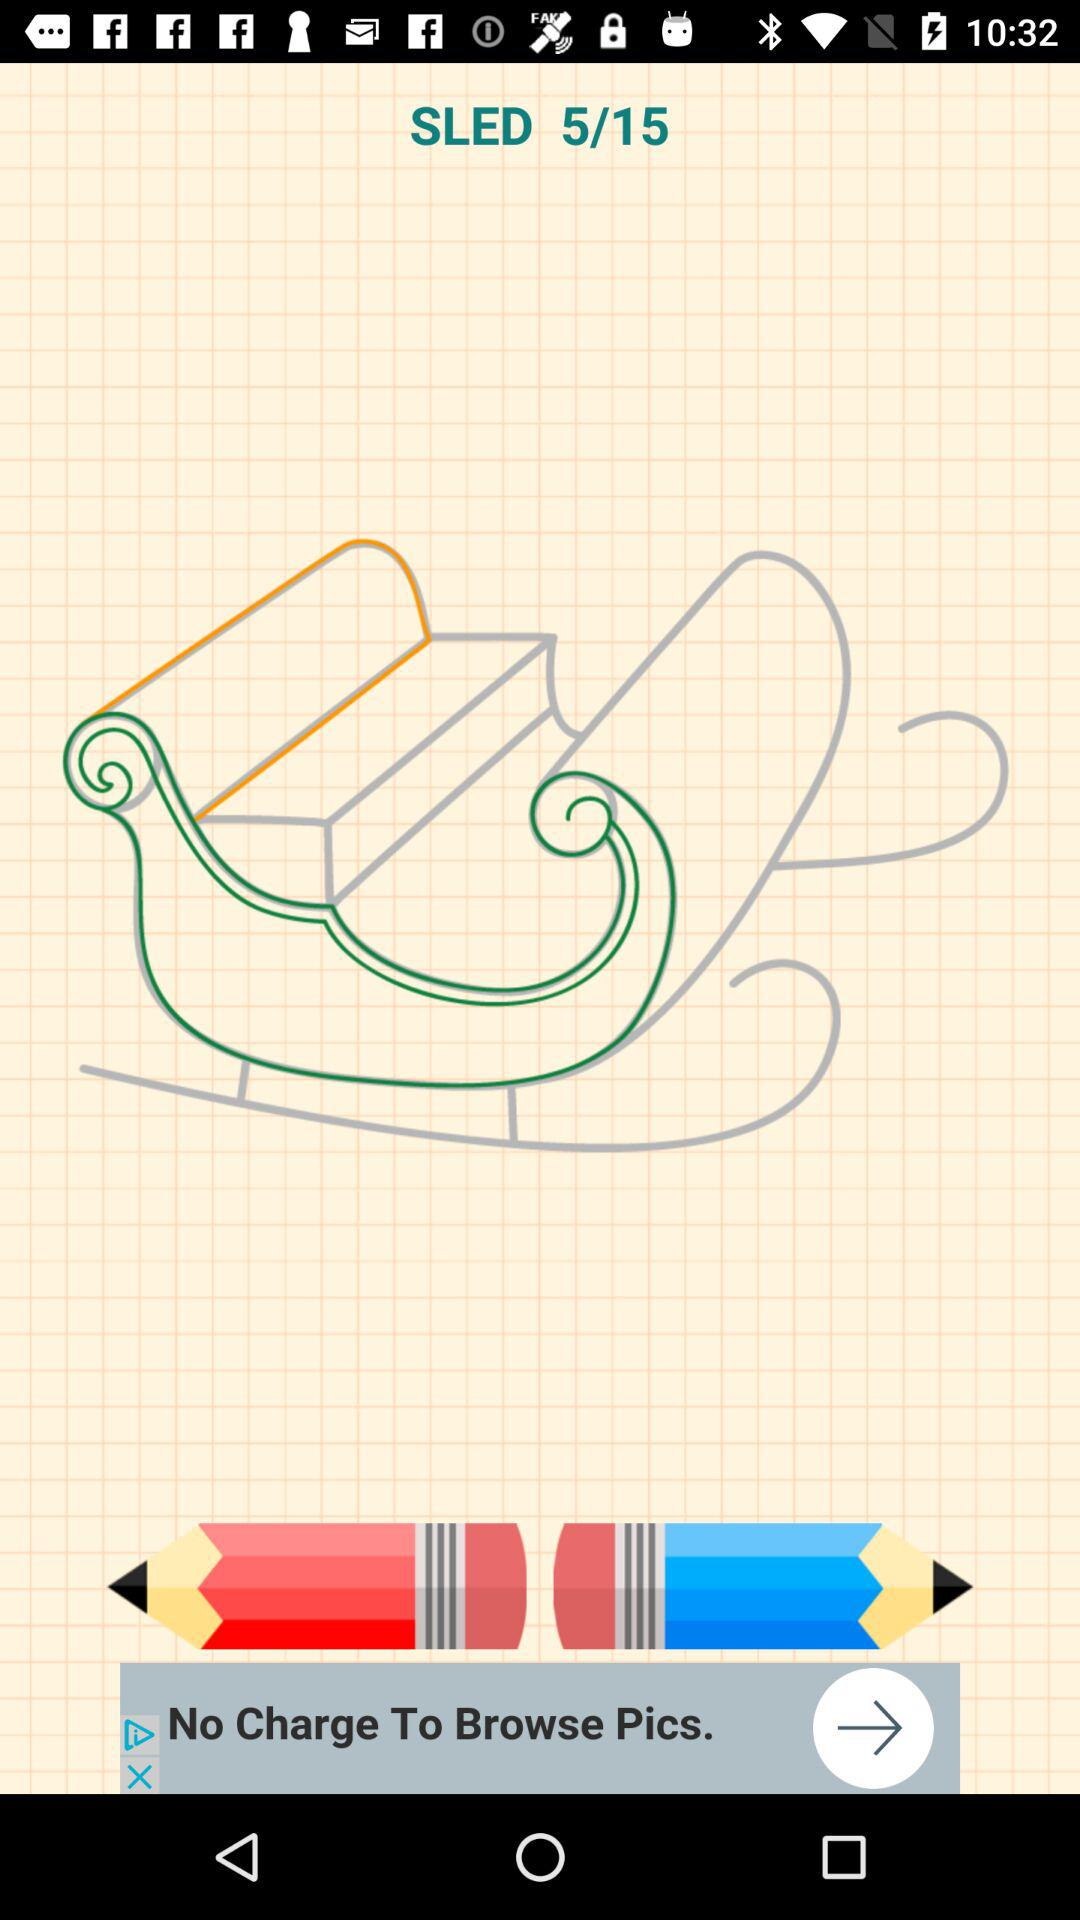How many pages are there? There are 15 pages. 